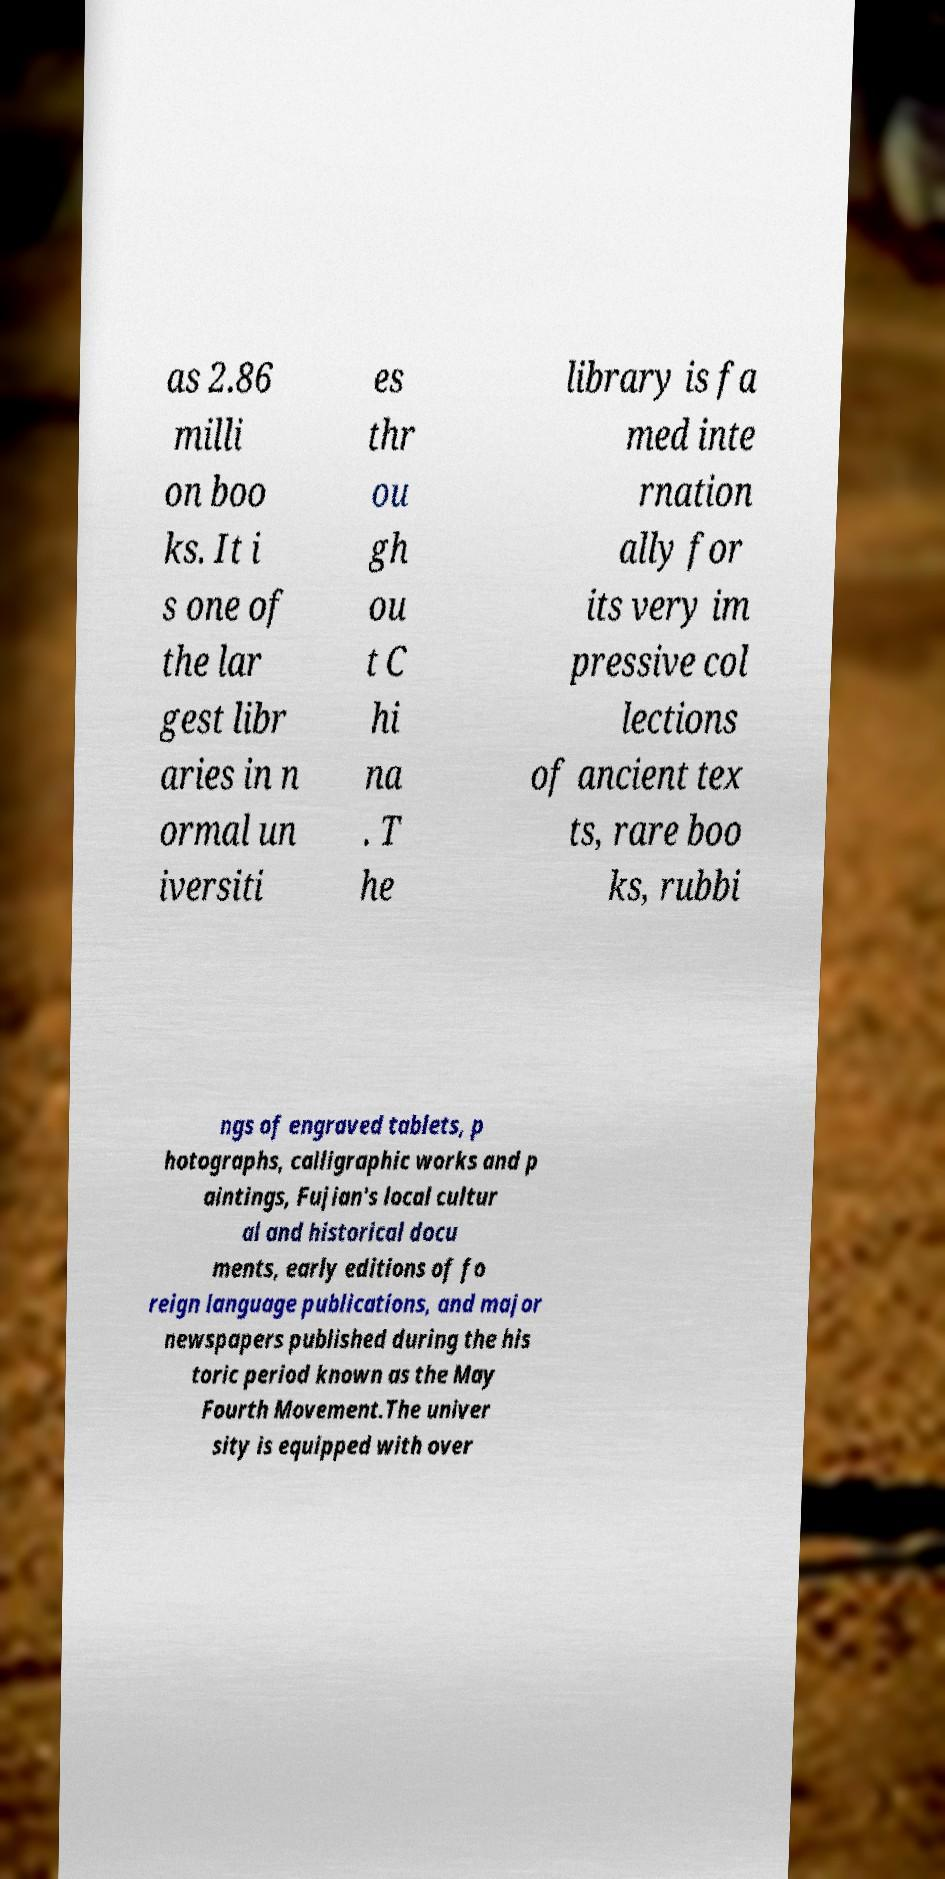Can you read and provide the text displayed in the image?This photo seems to have some interesting text. Can you extract and type it out for me? as 2.86 milli on boo ks. It i s one of the lar gest libr aries in n ormal un iversiti es thr ou gh ou t C hi na . T he library is fa med inte rnation ally for its very im pressive col lections of ancient tex ts, rare boo ks, rubbi ngs of engraved tablets, p hotographs, calligraphic works and p aintings, Fujian's local cultur al and historical docu ments, early editions of fo reign language publications, and major newspapers published during the his toric period known as the May Fourth Movement.The univer sity is equipped with over 